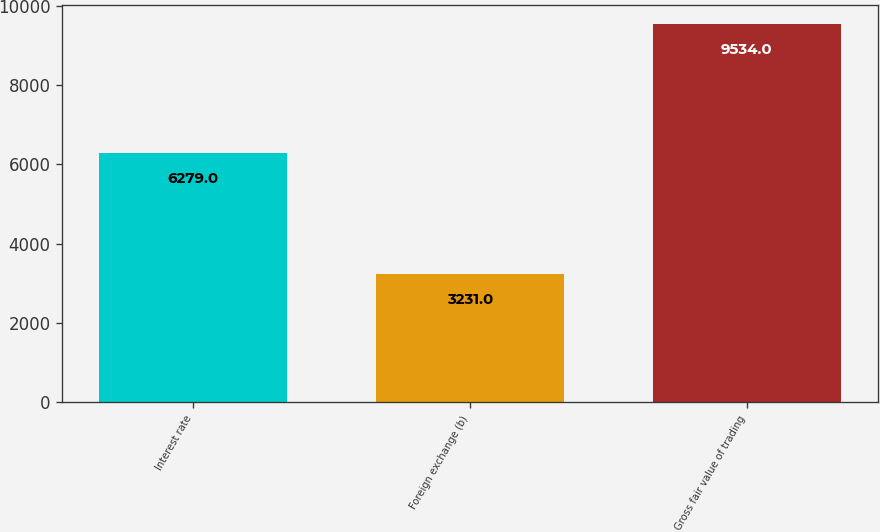<chart> <loc_0><loc_0><loc_500><loc_500><bar_chart><fcel>Interest rate<fcel>Foreign exchange (b)<fcel>Gross fair value of trading<nl><fcel>6279<fcel>3231<fcel>9534<nl></chart> 